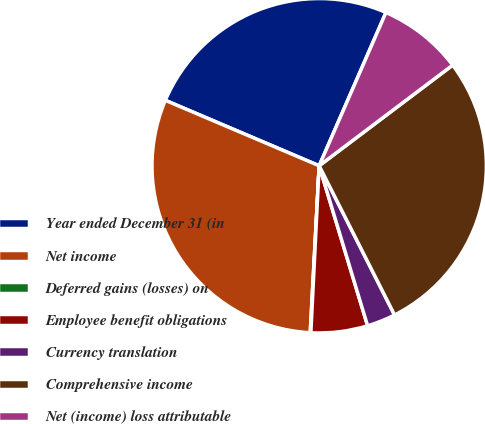Convert chart. <chart><loc_0><loc_0><loc_500><loc_500><pie_chart><fcel>Year ended December 31 (in<fcel>Net income<fcel>Deferred gains (losses) on<fcel>Employee benefit obligations<fcel>Currency translation<fcel>Comprehensive income<fcel>Net (income) loss attributable<nl><fcel>25.14%<fcel>30.55%<fcel>0.06%<fcel>5.47%<fcel>2.77%<fcel>27.84%<fcel>8.18%<nl></chart> 